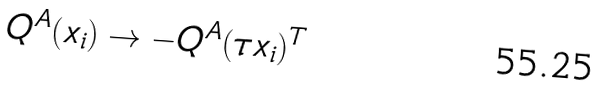Convert formula to latex. <formula><loc_0><loc_0><loc_500><loc_500>Q ^ { A } ( x _ { i } ) & \rightarrow - Q ^ { A } ( \tau x _ { i } ) ^ { T }</formula> 